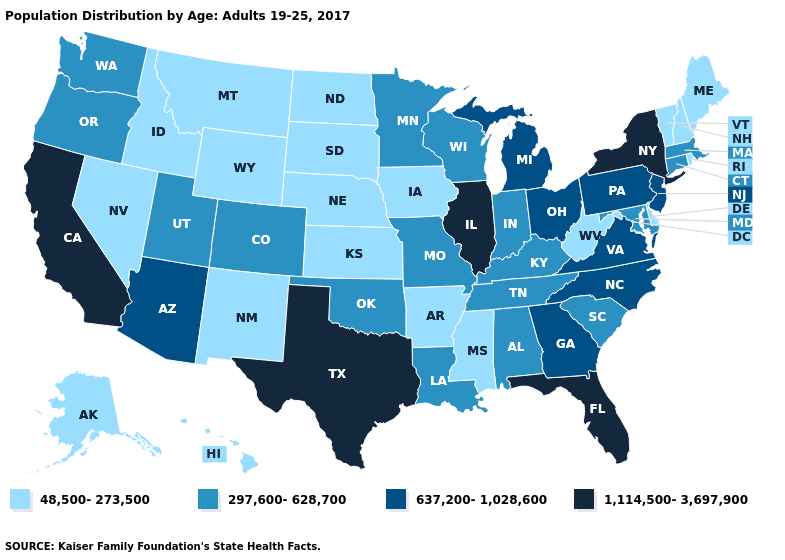What is the lowest value in states that border Utah?
Be succinct. 48,500-273,500. Does Georgia have a lower value than New York?
Short answer required. Yes. What is the value of Colorado?
Concise answer only. 297,600-628,700. Which states have the highest value in the USA?
Quick response, please. California, Florida, Illinois, New York, Texas. Among the states that border Utah , does Colorado have the highest value?
Short answer required. No. What is the highest value in states that border Florida?
Be succinct. 637,200-1,028,600. Which states have the highest value in the USA?
Give a very brief answer. California, Florida, Illinois, New York, Texas. What is the value of North Dakota?
Be succinct. 48,500-273,500. What is the value of Vermont?
Write a very short answer. 48,500-273,500. Name the states that have a value in the range 1,114,500-3,697,900?
Concise answer only. California, Florida, Illinois, New York, Texas. What is the highest value in the Northeast ?
Write a very short answer. 1,114,500-3,697,900. What is the value of Arkansas?
Keep it brief. 48,500-273,500. Name the states that have a value in the range 1,114,500-3,697,900?
Give a very brief answer. California, Florida, Illinois, New York, Texas. Does the first symbol in the legend represent the smallest category?
Give a very brief answer. Yes. Name the states that have a value in the range 297,600-628,700?
Short answer required. Alabama, Colorado, Connecticut, Indiana, Kentucky, Louisiana, Maryland, Massachusetts, Minnesota, Missouri, Oklahoma, Oregon, South Carolina, Tennessee, Utah, Washington, Wisconsin. 